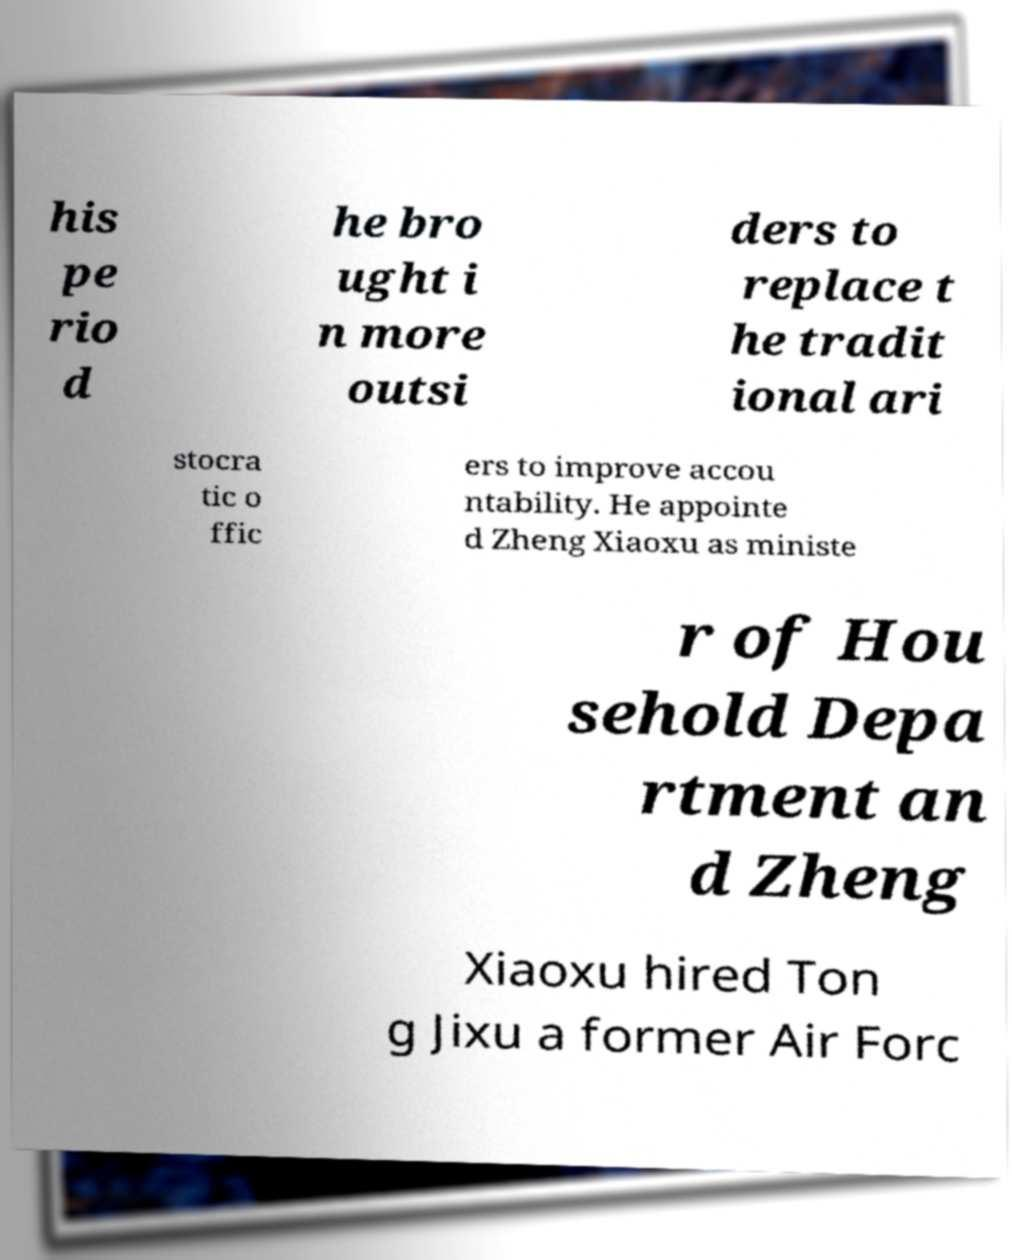Could you extract and type out the text from this image? his pe rio d he bro ught i n more outsi ders to replace t he tradit ional ari stocra tic o ffic ers to improve accou ntability. He appointe d Zheng Xiaoxu as ministe r of Hou sehold Depa rtment an d Zheng Xiaoxu hired Ton g Jixu a former Air Forc 